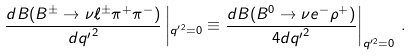Convert formula to latex. <formula><loc_0><loc_0><loc_500><loc_500>\frac { d B ( B ^ { \pm } \to \nu \ell ^ { \pm } \pi ^ { + } \pi ^ { - } ) } { d { q ^ { \prime } } ^ { 2 } } \left | _ { { q ^ { \prime } } ^ { 2 } = 0 } \equiv \frac { d B ( B ^ { 0 } \to \nu e ^ { - } \rho ^ { + } ) } { 4 d { q ^ { \prime } } ^ { 2 } } \right | _ { { q ^ { \prime } } ^ { 2 } = 0 } \, .</formula> 